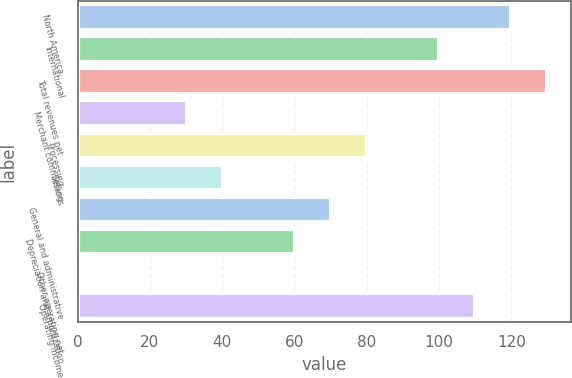<chart> <loc_0><loc_0><loc_500><loc_500><bar_chart><fcel>North America<fcel>International<fcel>Total revenues net<fcel>Merchant commissions<fcel>Processing<fcel>Selling<fcel>General and administrative<fcel>Depreciation and amortization<fcel>Other operating net<fcel>Operating income<nl><fcel>119.96<fcel>100<fcel>129.94<fcel>30.14<fcel>80.04<fcel>40.12<fcel>70.06<fcel>60.08<fcel>0.2<fcel>109.98<nl></chart> 